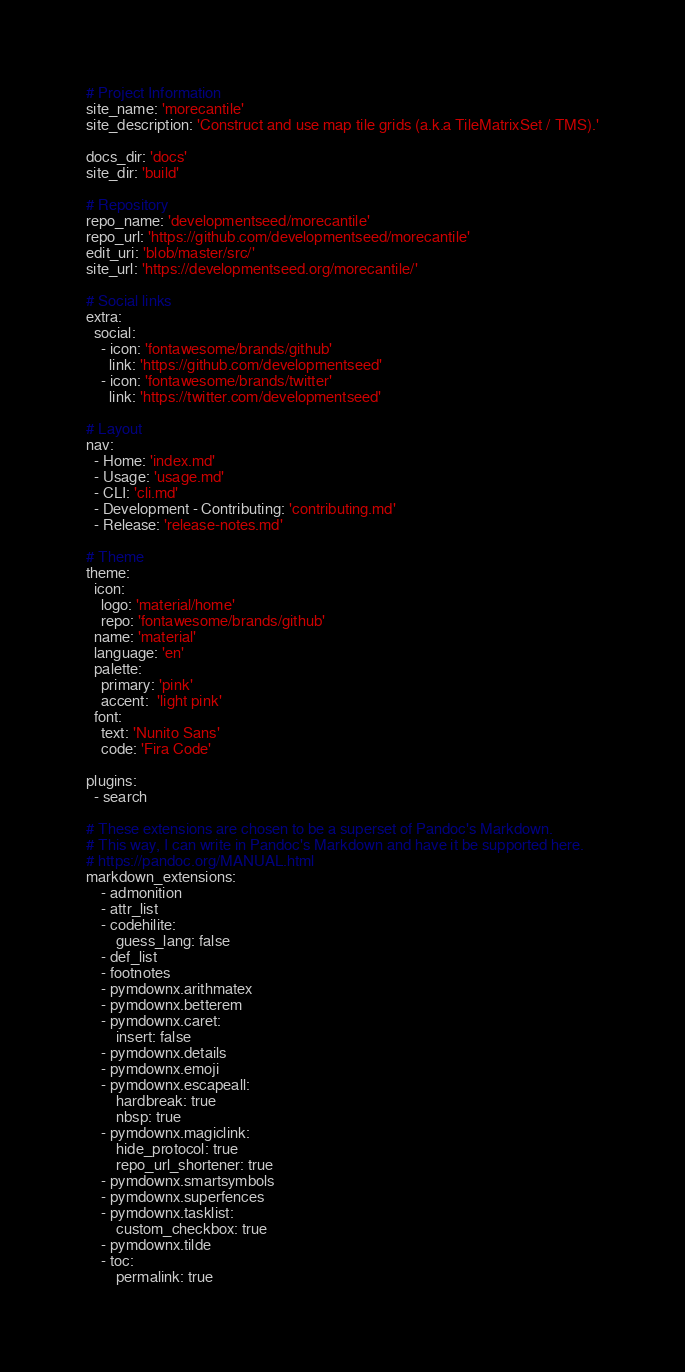Convert code to text. <code><loc_0><loc_0><loc_500><loc_500><_YAML_># Project Information
site_name: 'morecantile'
site_description: 'Construct and use map tile grids (a.k.a TileMatrixSet / TMS).'

docs_dir: 'docs'
site_dir: 'build'

# Repository
repo_name: 'developmentseed/morecantile'
repo_url: 'https://github.com/developmentseed/morecantile'
edit_uri: 'blob/master/src/'
site_url: 'https://developmentseed.org/morecantile/'

# Social links
extra:
  social:
    - icon: 'fontawesome/brands/github'
      link: 'https://github.com/developmentseed'
    - icon: 'fontawesome/brands/twitter'
      link: 'https://twitter.com/developmentseed'

# Layout
nav:
  - Home: 'index.md'
  - Usage: 'usage.md'
  - CLI: 'cli.md'
  - Development - Contributing: 'contributing.md'
  - Release: 'release-notes.md'

# Theme
theme:
  icon:
    logo: 'material/home'
    repo: 'fontawesome/brands/github'
  name: 'material'
  language: 'en'
  palette:
    primary: 'pink'
    accent:  'light pink'
  font:
    text: 'Nunito Sans'
    code: 'Fira Code'

plugins:
  - search

# These extensions are chosen to be a superset of Pandoc's Markdown.
# This way, I can write in Pandoc's Markdown and have it be supported here.
# https://pandoc.org/MANUAL.html
markdown_extensions:
    - admonition
    - attr_list
    - codehilite:
        guess_lang: false
    - def_list
    - footnotes
    - pymdownx.arithmatex
    - pymdownx.betterem
    - pymdownx.caret:
        insert: false
    - pymdownx.details
    - pymdownx.emoji
    - pymdownx.escapeall:
        hardbreak: true
        nbsp: true
    - pymdownx.magiclink:
        hide_protocol: true
        repo_url_shortener: true
    - pymdownx.smartsymbols
    - pymdownx.superfences
    - pymdownx.tasklist:
        custom_checkbox: true
    - pymdownx.tilde
    - toc:
        permalink: true
</code> 